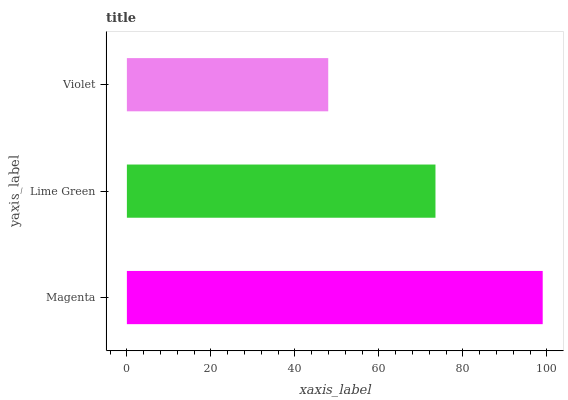Is Violet the minimum?
Answer yes or no. Yes. Is Magenta the maximum?
Answer yes or no. Yes. Is Lime Green the minimum?
Answer yes or no. No. Is Lime Green the maximum?
Answer yes or no. No. Is Magenta greater than Lime Green?
Answer yes or no. Yes. Is Lime Green less than Magenta?
Answer yes or no. Yes. Is Lime Green greater than Magenta?
Answer yes or no. No. Is Magenta less than Lime Green?
Answer yes or no. No. Is Lime Green the high median?
Answer yes or no. Yes. Is Lime Green the low median?
Answer yes or no. Yes. Is Magenta the high median?
Answer yes or no. No. Is Magenta the low median?
Answer yes or no. No. 